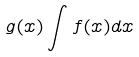Convert formula to latex. <formula><loc_0><loc_0><loc_500><loc_500>g ( x ) \int f ( x ) d x</formula> 